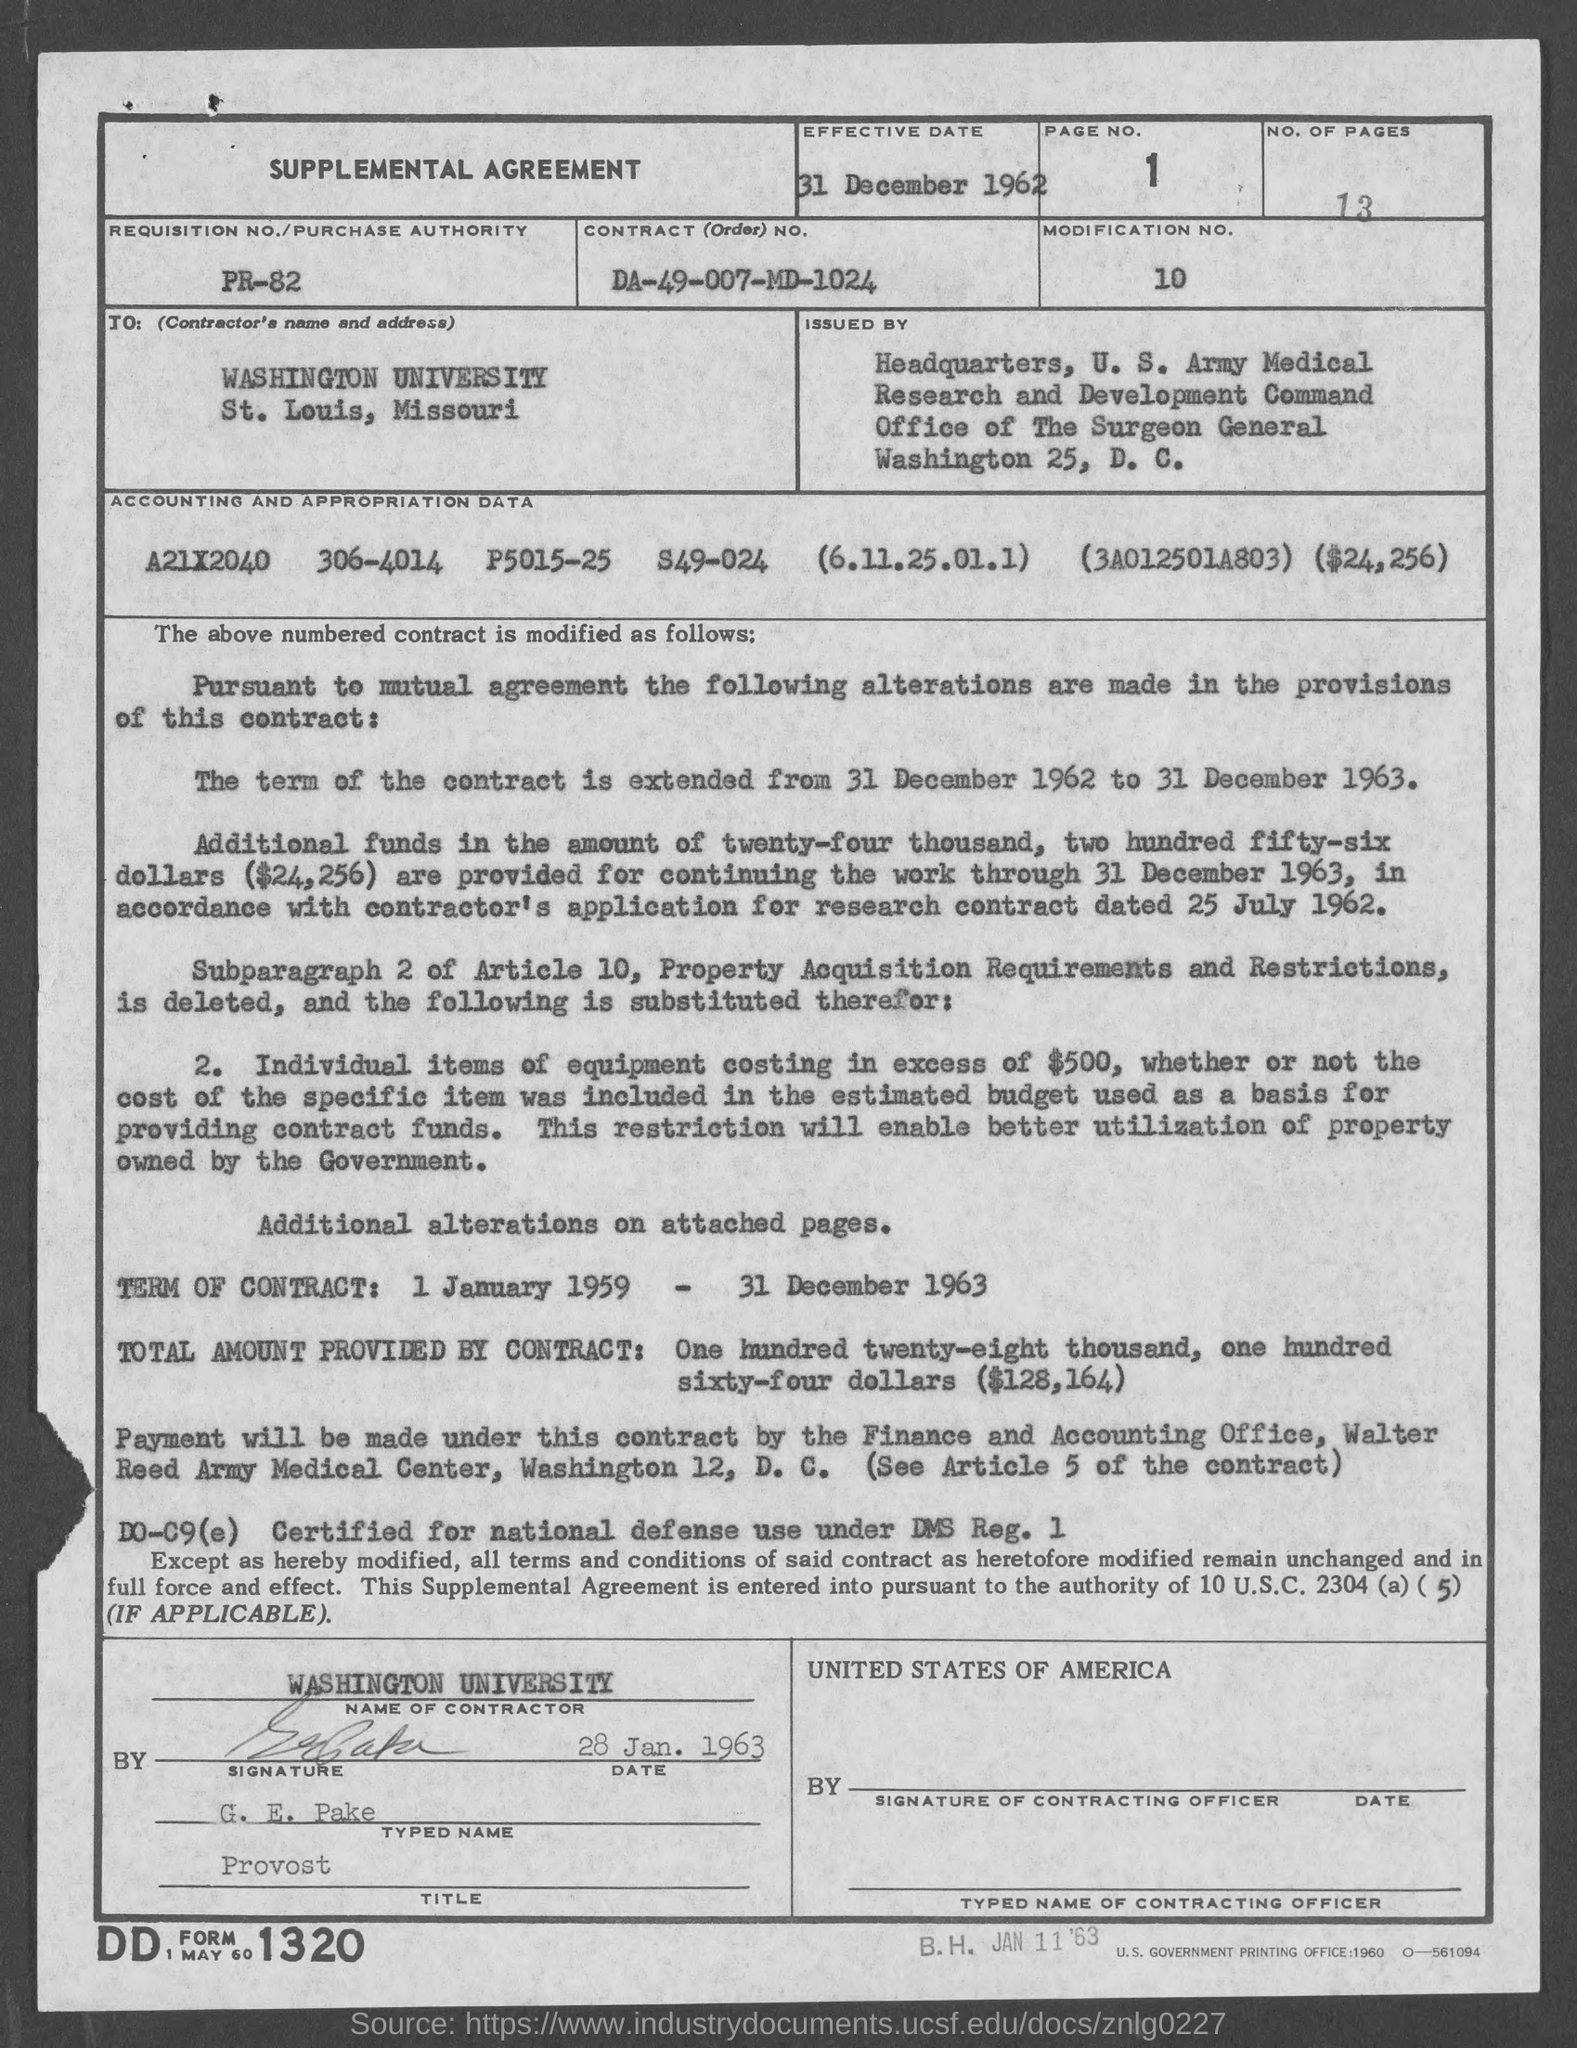Please summarize the content of the 'SUPPLEMENTAL AGREEMENT' section. The 'SUPPLEMENTAL AGREEMENT' section indicates modifications to a contract, including an extension of the term and the provision of additional funds totaling $24,256 for continued work through 31 December 1963. It also notes changes related to property acquisition requirements. 